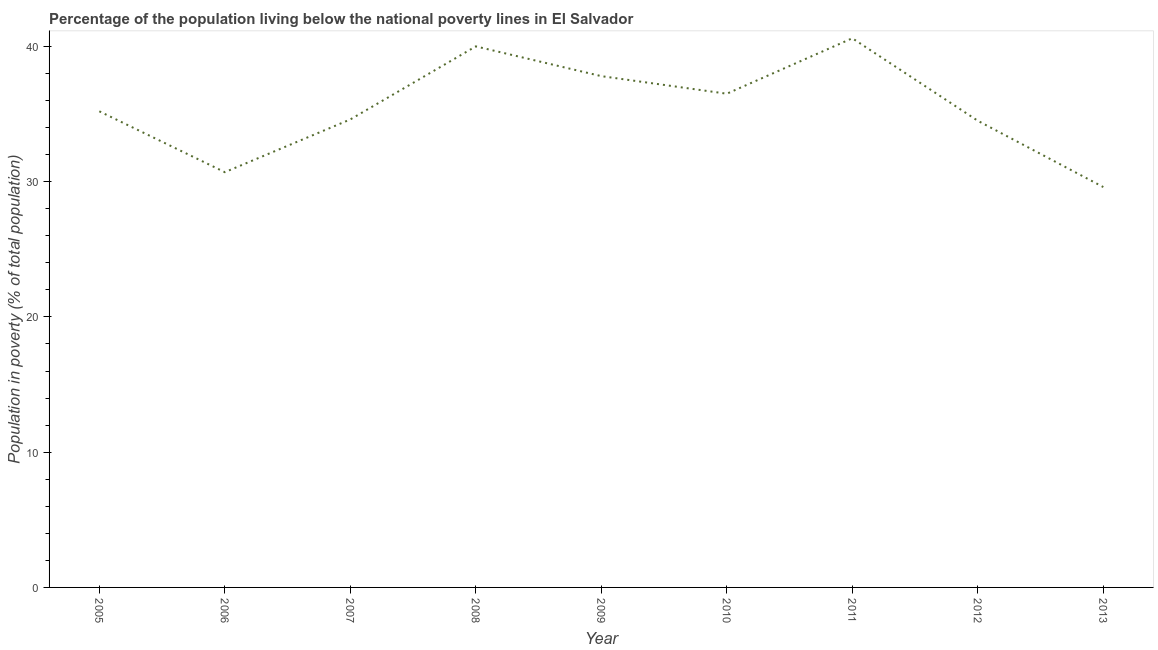Across all years, what is the maximum percentage of population living below poverty line?
Provide a short and direct response. 40.6. Across all years, what is the minimum percentage of population living below poverty line?
Your answer should be compact. 29.6. In which year was the percentage of population living below poverty line maximum?
Your response must be concise. 2011. In which year was the percentage of population living below poverty line minimum?
Your answer should be very brief. 2013. What is the sum of the percentage of population living below poverty line?
Your answer should be compact. 319.5. What is the difference between the percentage of population living below poverty line in 2012 and 2013?
Offer a very short reply. 4.9. What is the average percentage of population living below poverty line per year?
Your answer should be compact. 35.5. What is the median percentage of population living below poverty line?
Make the answer very short. 35.2. In how many years, is the percentage of population living below poverty line greater than 34 %?
Provide a succinct answer. 7. What is the ratio of the percentage of population living below poverty line in 2011 to that in 2012?
Give a very brief answer. 1.18. Is the difference between the percentage of population living below poverty line in 2009 and 2012 greater than the difference between any two years?
Offer a terse response. No. What is the difference between the highest and the second highest percentage of population living below poverty line?
Offer a very short reply. 0.6. What is the difference between the highest and the lowest percentage of population living below poverty line?
Your answer should be compact. 11. In how many years, is the percentage of population living below poverty line greater than the average percentage of population living below poverty line taken over all years?
Offer a terse response. 4. How many lines are there?
Your answer should be compact. 1. What is the difference between two consecutive major ticks on the Y-axis?
Offer a very short reply. 10. What is the title of the graph?
Your answer should be very brief. Percentage of the population living below the national poverty lines in El Salvador. What is the label or title of the Y-axis?
Your answer should be very brief. Population in poverty (% of total population). What is the Population in poverty (% of total population) of 2005?
Provide a short and direct response. 35.2. What is the Population in poverty (% of total population) in 2006?
Provide a succinct answer. 30.7. What is the Population in poverty (% of total population) of 2007?
Your answer should be compact. 34.6. What is the Population in poverty (% of total population) of 2009?
Your answer should be very brief. 37.8. What is the Population in poverty (% of total population) of 2010?
Make the answer very short. 36.5. What is the Population in poverty (% of total population) of 2011?
Make the answer very short. 40.6. What is the Population in poverty (% of total population) of 2012?
Give a very brief answer. 34.5. What is the Population in poverty (% of total population) in 2013?
Ensure brevity in your answer.  29.6. What is the difference between the Population in poverty (% of total population) in 2005 and 2007?
Ensure brevity in your answer.  0.6. What is the difference between the Population in poverty (% of total population) in 2005 and 2008?
Your response must be concise. -4.8. What is the difference between the Population in poverty (% of total population) in 2005 and 2009?
Provide a short and direct response. -2.6. What is the difference between the Population in poverty (% of total population) in 2005 and 2011?
Your response must be concise. -5.4. What is the difference between the Population in poverty (% of total population) in 2005 and 2013?
Make the answer very short. 5.6. What is the difference between the Population in poverty (% of total population) in 2006 and 2013?
Ensure brevity in your answer.  1.1. What is the difference between the Population in poverty (% of total population) in 2007 and 2009?
Offer a very short reply. -3.2. What is the difference between the Population in poverty (% of total population) in 2007 and 2010?
Keep it short and to the point. -1.9. What is the difference between the Population in poverty (% of total population) in 2007 and 2011?
Provide a short and direct response. -6. What is the difference between the Population in poverty (% of total population) in 2007 and 2013?
Ensure brevity in your answer.  5. What is the difference between the Population in poverty (% of total population) in 2008 and 2009?
Your response must be concise. 2.2. What is the difference between the Population in poverty (% of total population) in 2008 and 2010?
Make the answer very short. 3.5. What is the difference between the Population in poverty (% of total population) in 2008 and 2012?
Offer a terse response. 5.5. What is the difference between the Population in poverty (% of total population) in 2008 and 2013?
Offer a very short reply. 10.4. What is the difference between the Population in poverty (% of total population) in 2009 and 2011?
Offer a terse response. -2.8. What is the difference between the Population in poverty (% of total population) in 2009 and 2012?
Offer a very short reply. 3.3. What is the difference between the Population in poverty (% of total population) in 2010 and 2012?
Provide a short and direct response. 2. What is the difference between the Population in poverty (% of total population) in 2011 and 2012?
Your response must be concise. 6.1. What is the difference between the Population in poverty (% of total population) in 2011 and 2013?
Your response must be concise. 11. What is the ratio of the Population in poverty (% of total population) in 2005 to that in 2006?
Your answer should be compact. 1.15. What is the ratio of the Population in poverty (% of total population) in 2005 to that in 2007?
Give a very brief answer. 1.02. What is the ratio of the Population in poverty (% of total population) in 2005 to that in 2008?
Provide a short and direct response. 0.88. What is the ratio of the Population in poverty (% of total population) in 2005 to that in 2009?
Offer a very short reply. 0.93. What is the ratio of the Population in poverty (% of total population) in 2005 to that in 2010?
Your answer should be compact. 0.96. What is the ratio of the Population in poverty (% of total population) in 2005 to that in 2011?
Provide a succinct answer. 0.87. What is the ratio of the Population in poverty (% of total population) in 2005 to that in 2012?
Your response must be concise. 1.02. What is the ratio of the Population in poverty (% of total population) in 2005 to that in 2013?
Ensure brevity in your answer.  1.19. What is the ratio of the Population in poverty (% of total population) in 2006 to that in 2007?
Provide a short and direct response. 0.89. What is the ratio of the Population in poverty (% of total population) in 2006 to that in 2008?
Provide a succinct answer. 0.77. What is the ratio of the Population in poverty (% of total population) in 2006 to that in 2009?
Keep it short and to the point. 0.81. What is the ratio of the Population in poverty (% of total population) in 2006 to that in 2010?
Your response must be concise. 0.84. What is the ratio of the Population in poverty (% of total population) in 2006 to that in 2011?
Offer a very short reply. 0.76. What is the ratio of the Population in poverty (% of total population) in 2006 to that in 2012?
Ensure brevity in your answer.  0.89. What is the ratio of the Population in poverty (% of total population) in 2006 to that in 2013?
Provide a succinct answer. 1.04. What is the ratio of the Population in poverty (% of total population) in 2007 to that in 2008?
Your answer should be very brief. 0.86. What is the ratio of the Population in poverty (% of total population) in 2007 to that in 2009?
Offer a very short reply. 0.92. What is the ratio of the Population in poverty (% of total population) in 2007 to that in 2010?
Provide a succinct answer. 0.95. What is the ratio of the Population in poverty (% of total population) in 2007 to that in 2011?
Provide a succinct answer. 0.85. What is the ratio of the Population in poverty (% of total population) in 2007 to that in 2013?
Provide a succinct answer. 1.17. What is the ratio of the Population in poverty (% of total population) in 2008 to that in 2009?
Your response must be concise. 1.06. What is the ratio of the Population in poverty (% of total population) in 2008 to that in 2010?
Your answer should be very brief. 1.1. What is the ratio of the Population in poverty (% of total population) in 2008 to that in 2011?
Provide a short and direct response. 0.98. What is the ratio of the Population in poverty (% of total population) in 2008 to that in 2012?
Give a very brief answer. 1.16. What is the ratio of the Population in poverty (% of total population) in 2008 to that in 2013?
Provide a short and direct response. 1.35. What is the ratio of the Population in poverty (% of total population) in 2009 to that in 2010?
Provide a succinct answer. 1.04. What is the ratio of the Population in poverty (% of total population) in 2009 to that in 2011?
Your answer should be compact. 0.93. What is the ratio of the Population in poverty (% of total population) in 2009 to that in 2012?
Keep it short and to the point. 1.1. What is the ratio of the Population in poverty (% of total population) in 2009 to that in 2013?
Ensure brevity in your answer.  1.28. What is the ratio of the Population in poverty (% of total population) in 2010 to that in 2011?
Offer a terse response. 0.9. What is the ratio of the Population in poverty (% of total population) in 2010 to that in 2012?
Provide a succinct answer. 1.06. What is the ratio of the Population in poverty (% of total population) in 2010 to that in 2013?
Ensure brevity in your answer.  1.23. What is the ratio of the Population in poverty (% of total population) in 2011 to that in 2012?
Make the answer very short. 1.18. What is the ratio of the Population in poverty (% of total population) in 2011 to that in 2013?
Give a very brief answer. 1.37. What is the ratio of the Population in poverty (% of total population) in 2012 to that in 2013?
Provide a short and direct response. 1.17. 